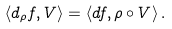Convert formula to latex. <formula><loc_0><loc_0><loc_500><loc_500>\langle d _ { \rho } f , V \rangle = \langle d f , \rho \circ V \rangle \, .</formula> 